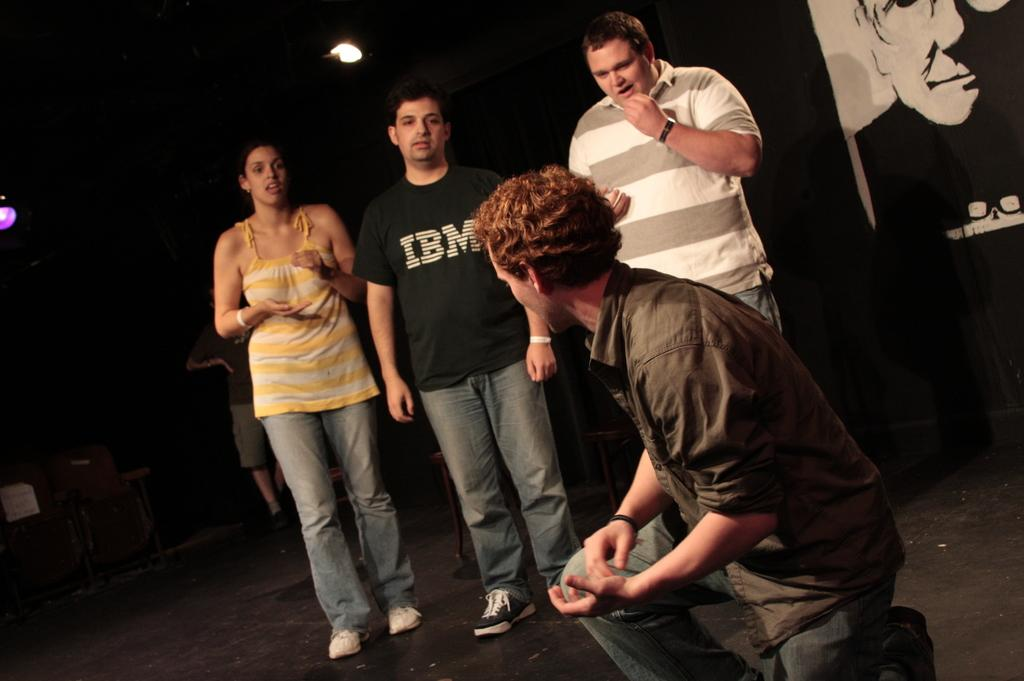What is happening in the image? There are four persons performing an act on stage. Can you describe any additional elements in the image? Yes, there is a poster in the top right corner of the image. How many legs does the dog have in the image? There is no dog present in the image. What type of calculator is being used by the performers on stage? There is no calculator visible in the image. 